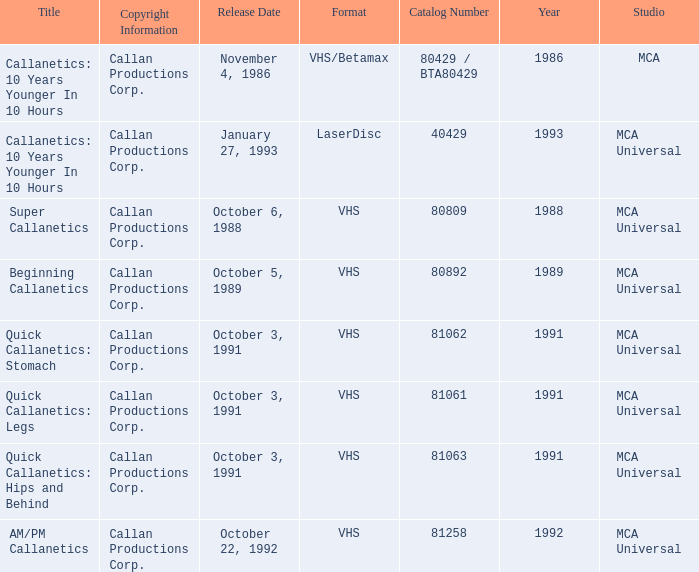Name the catalog number for  october 6, 1988 80809.0. 